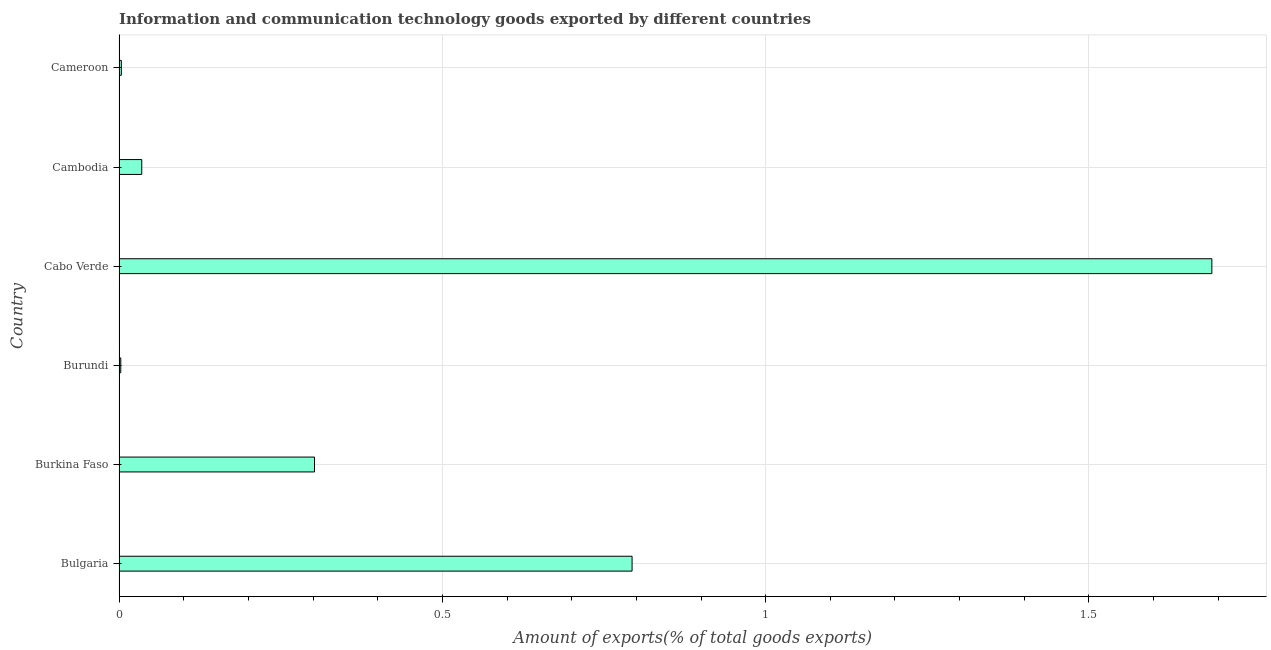Does the graph contain grids?
Provide a short and direct response. Yes. What is the title of the graph?
Provide a short and direct response. Information and communication technology goods exported by different countries. What is the label or title of the X-axis?
Your answer should be compact. Amount of exports(% of total goods exports). What is the amount of ict goods exports in Cameroon?
Your answer should be compact. 0. Across all countries, what is the maximum amount of ict goods exports?
Ensure brevity in your answer.  1.69. Across all countries, what is the minimum amount of ict goods exports?
Offer a very short reply. 0. In which country was the amount of ict goods exports maximum?
Your answer should be compact. Cabo Verde. In which country was the amount of ict goods exports minimum?
Provide a succinct answer. Burundi. What is the sum of the amount of ict goods exports?
Keep it short and to the point. 2.83. What is the difference between the amount of ict goods exports in Bulgaria and Burkina Faso?
Your answer should be very brief. 0.49. What is the average amount of ict goods exports per country?
Keep it short and to the point. 0.47. What is the median amount of ict goods exports?
Your answer should be very brief. 0.17. In how many countries, is the amount of ict goods exports greater than 1.2 %?
Provide a succinct answer. 1. What is the ratio of the amount of ict goods exports in Burkina Faso to that in Cambodia?
Your response must be concise. 8.61. Is the amount of ict goods exports in Burkina Faso less than that in Cameroon?
Provide a short and direct response. No. Is the difference between the amount of ict goods exports in Burkina Faso and Cambodia greater than the difference between any two countries?
Provide a short and direct response. No. What is the difference between the highest and the second highest amount of ict goods exports?
Offer a very short reply. 0.9. Is the sum of the amount of ict goods exports in Burkina Faso and Cameroon greater than the maximum amount of ict goods exports across all countries?
Provide a succinct answer. No. What is the difference between the highest and the lowest amount of ict goods exports?
Your answer should be very brief. 1.69. Are the values on the major ticks of X-axis written in scientific E-notation?
Your answer should be very brief. No. What is the Amount of exports(% of total goods exports) of Bulgaria?
Provide a short and direct response. 0.79. What is the Amount of exports(% of total goods exports) in Burkina Faso?
Make the answer very short. 0.3. What is the Amount of exports(% of total goods exports) of Burundi?
Keep it short and to the point. 0. What is the Amount of exports(% of total goods exports) of Cabo Verde?
Your answer should be very brief. 1.69. What is the Amount of exports(% of total goods exports) in Cambodia?
Your answer should be compact. 0.04. What is the Amount of exports(% of total goods exports) of Cameroon?
Ensure brevity in your answer.  0. What is the difference between the Amount of exports(% of total goods exports) in Bulgaria and Burkina Faso?
Give a very brief answer. 0.49. What is the difference between the Amount of exports(% of total goods exports) in Bulgaria and Burundi?
Your response must be concise. 0.79. What is the difference between the Amount of exports(% of total goods exports) in Bulgaria and Cabo Verde?
Ensure brevity in your answer.  -0.9. What is the difference between the Amount of exports(% of total goods exports) in Bulgaria and Cambodia?
Keep it short and to the point. 0.76. What is the difference between the Amount of exports(% of total goods exports) in Bulgaria and Cameroon?
Offer a terse response. 0.79. What is the difference between the Amount of exports(% of total goods exports) in Burkina Faso and Burundi?
Your answer should be compact. 0.3. What is the difference between the Amount of exports(% of total goods exports) in Burkina Faso and Cabo Verde?
Provide a short and direct response. -1.39. What is the difference between the Amount of exports(% of total goods exports) in Burkina Faso and Cambodia?
Your answer should be very brief. 0.27. What is the difference between the Amount of exports(% of total goods exports) in Burkina Faso and Cameroon?
Give a very brief answer. 0.3. What is the difference between the Amount of exports(% of total goods exports) in Burundi and Cabo Verde?
Your answer should be compact. -1.69. What is the difference between the Amount of exports(% of total goods exports) in Burundi and Cambodia?
Ensure brevity in your answer.  -0.03. What is the difference between the Amount of exports(% of total goods exports) in Burundi and Cameroon?
Your answer should be very brief. -0. What is the difference between the Amount of exports(% of total goods exports) in Cabo Verde and Cambodia?
Make the answer very short. 1.65. What is the difference between the Amount of exports(% of total goods exports) in Cabo Verde and Cameroon?
Your answer should be very brief. 1.69. What is the difference between the Amount of exports(% of total goods exports) in Cambodia and Cameroon?
Your answer should be compact. 0.03. What is the ratio of the Amount of exports(% of total goods exports) in Bulgaria to that in Burkina Faso?
Your answer should be very brief. 2.62. What is the ratio of the Amount of exports(% of total goods exports) in Bulgaria to that in Burundi?
Make the answer very short. 299.31. What is the ratio of the Amount of exports(% of total goods exports) in Bulgaria to that in Cabo Verde?
Your answer should be compact. 0.47. What is the ratio of the Amount of exports(% of total goods exports) in Bulgaria to that in Cambodia?
Your answer should be very brief. 22.6. What is the ratio of the Amount of exports(% of total goods exports) in Bulgaria to that in Cameroon?
Ensure brevity in your answer.  223.21. What is the ratio of the Amount of exports(% of total goods exports) in Burkina Faso to that in Burundi?
Your answer should be very brief. 114.03. What is the ratio of the Amount of exports(% of total goods exports) in Burkina Faso to that in Cabo Verde?
Your response must be concise. 0.18. What is the ratio of the Amount of exports(% of total goods exports) in Burkina Faso to that in Cambodia?
Keep it short and to the point. 8.61. What is the ratio of the Amount of exports(% of total goods exports) in Burkina Faso to that in Cameroon?
Make the answer very short. 85.03. What is the ratio of the Amount of exports(% of total goods exports) in Burundi to that in Cabo Verde?
Provide a succinct answer. 0. What is the ratio of the Amount of exports(% of total goods exports) in Burundi to that in Cambodia?
Your answer should be compact. 0.08. What is the ratio of the Amount of exports(% of total goods exports) in Burundi to that in Cameroon?
Provide a succinct answer. 0.75. What is the ratio of the Amount of exports(% of total goods exports) in Cabo Verde to that in Cambodia?
Your response must be concise. 48.14. What is the ratio of the Amount of exports(% of total goods exports) in Cabo Verde to that in Cameroon?
Provide a succinct answer. 475.44. What is the ratio of the Amount of exports(% of total goods exports) in Cambodia to that in Cameroon?
Offer a very short reply. 9.88. 